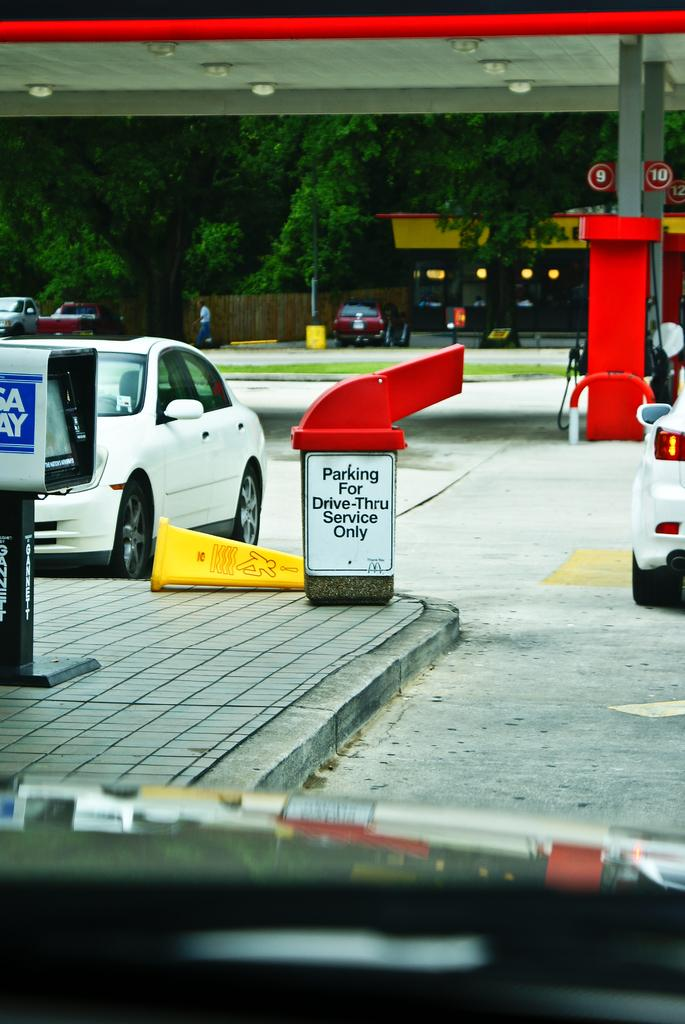<image>
Write a terse but informative summary of the picture. Sign on a dumpster that says "Parking For Drive-Thru Service Only". 